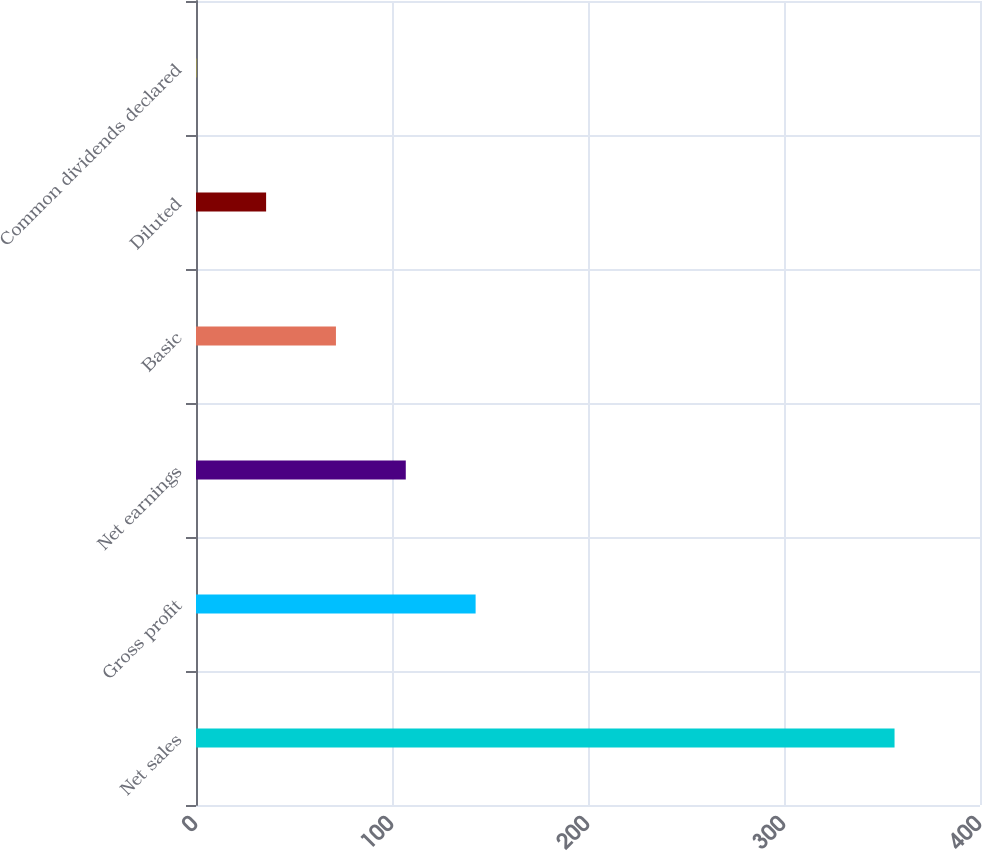<chart> <loc_0><loc_0><loc_500><loc_500><bar_chart><fcel>Net sales<fcel>Gross profit<fcel>Net earnings<fcel>Basic<fcel>Diluted<fcel>Common dividends declared<nl><fcel>356.4<fcel>142.66<fcel>107.03<fcel>71.4<fcel>35.77<fcel>0.15<nl></chart> 